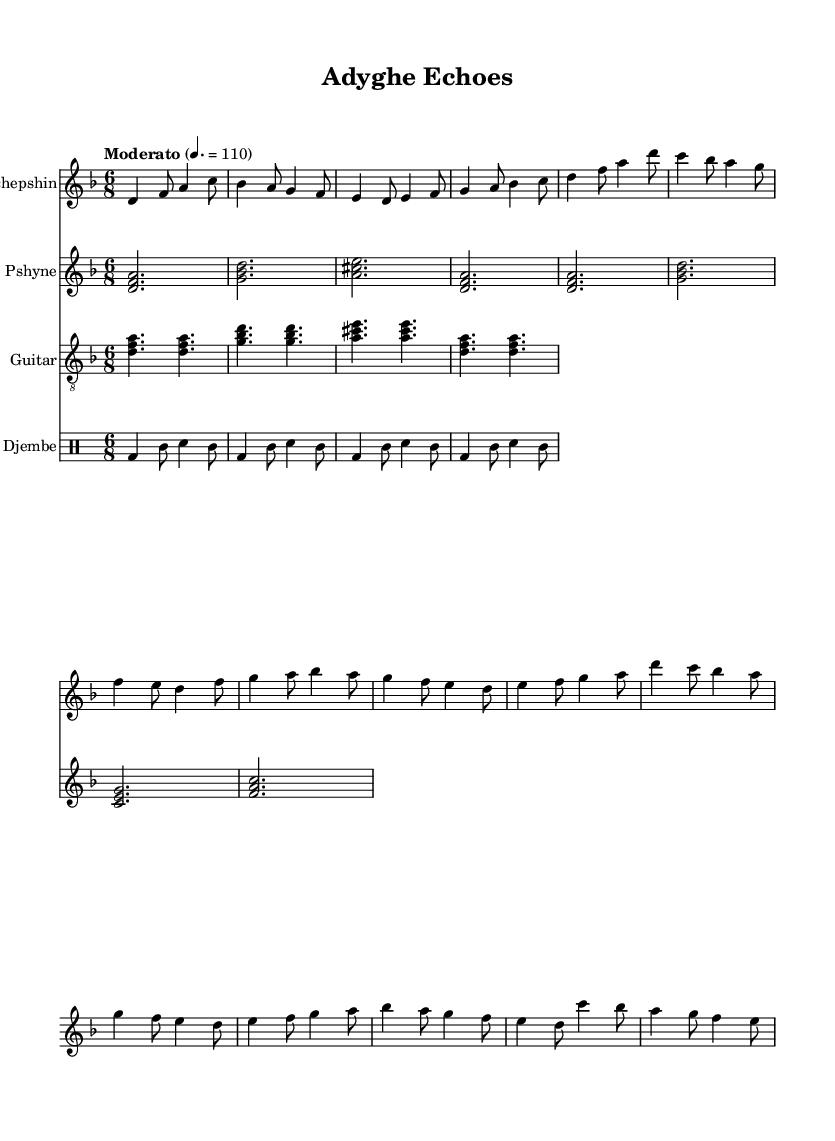What is the key signature of this music? The key signature is indicated at the beginning of the staff and shows two flats. This corresponds to the key of D minor.
Answer: D minor What is the time signature of the piece? The time signature is shown at the beginning of the music as 6/8, which means there are six eighth notes in a measure.
Answer: 6/8 What is the tempo marking for this piece? The tempo marking appears at the beginning, which states "Moderato" with a metronome marking of 110, indicating a moderate speed.
Answer: Moderato, 110 How many measures are in the chorus section? By counting the measures in the chorus part specified after the verse, we see that there are four measures in total.
Answer: 4 What type of rhythmic elements does the djembe part feature? The djembe rhythm includes bass drum and tambourine notes that create a repeating 6/8 pattern, common in folk traditions with a lively feel.
Answer: Bass and tambourine Which instruments are included in the score? The instruments listed in the score are Shichepshin, Pshyne, Guitar, and Djembe, showing a fusion of traditional and contemporary sounds.
Answer: Shichepshin, Pshyne, Guitar, Djembe What is the harmonic structure of the Pshyne section? The Pshyne section consists of chord clusters built on root positions, alternating between various triads providing harmonic support for the melody.
Answer: Root triads 